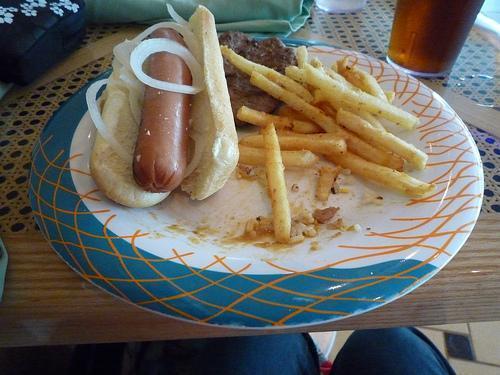How many brown drinks?
Give a very brief answer. 1. How many hotdogs?
Give a very brief answer. 1. 